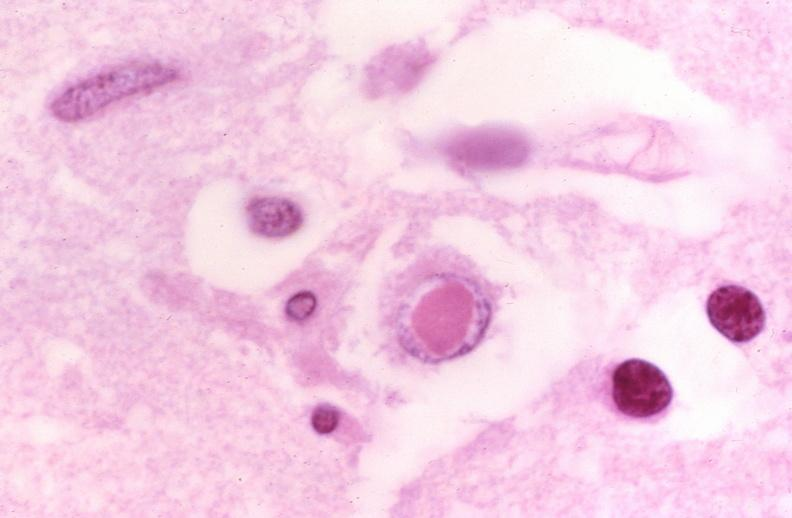does this image show brain, herpes inclusion bodies?
Answer the question using a single word or phrase. Yes 